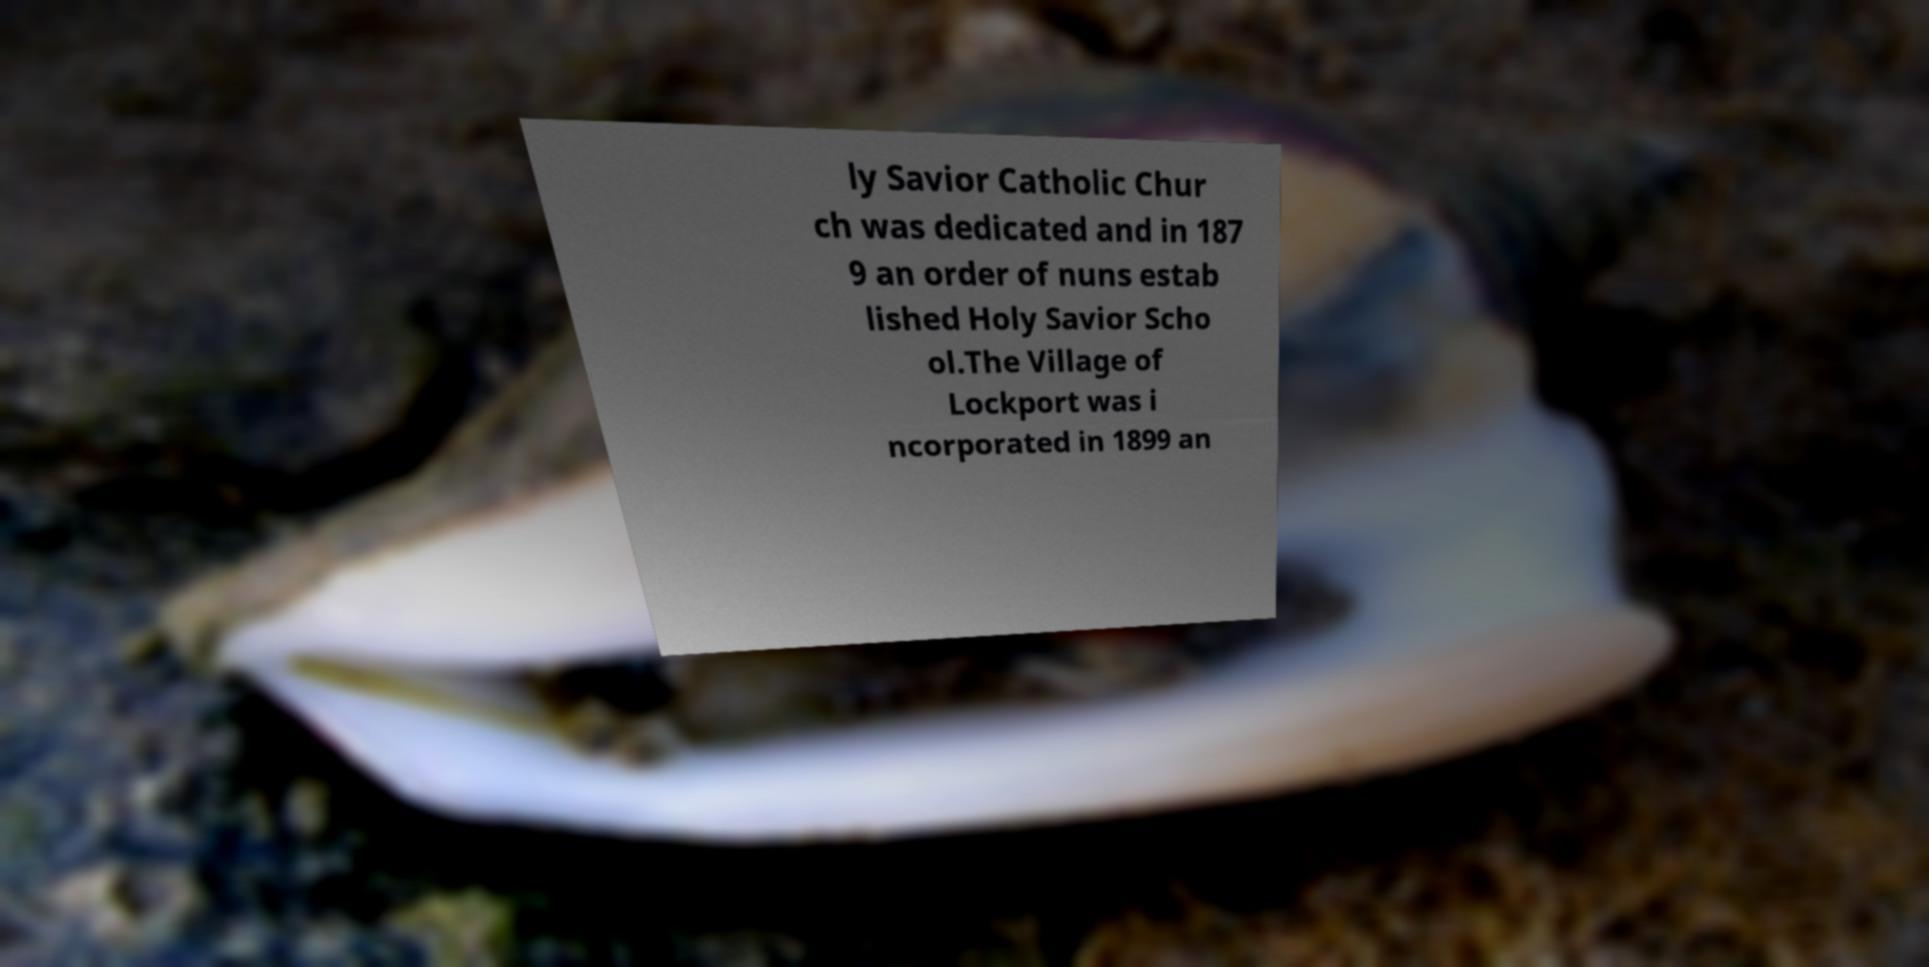Please identify and transcribe the text found in this image. ly Savior Catholic Chur ch was dedicated and in 187 9 an order of nuns estab lished Holy Savior Scho ol.The Village of Lockport was i ncorporated in 1899 an 